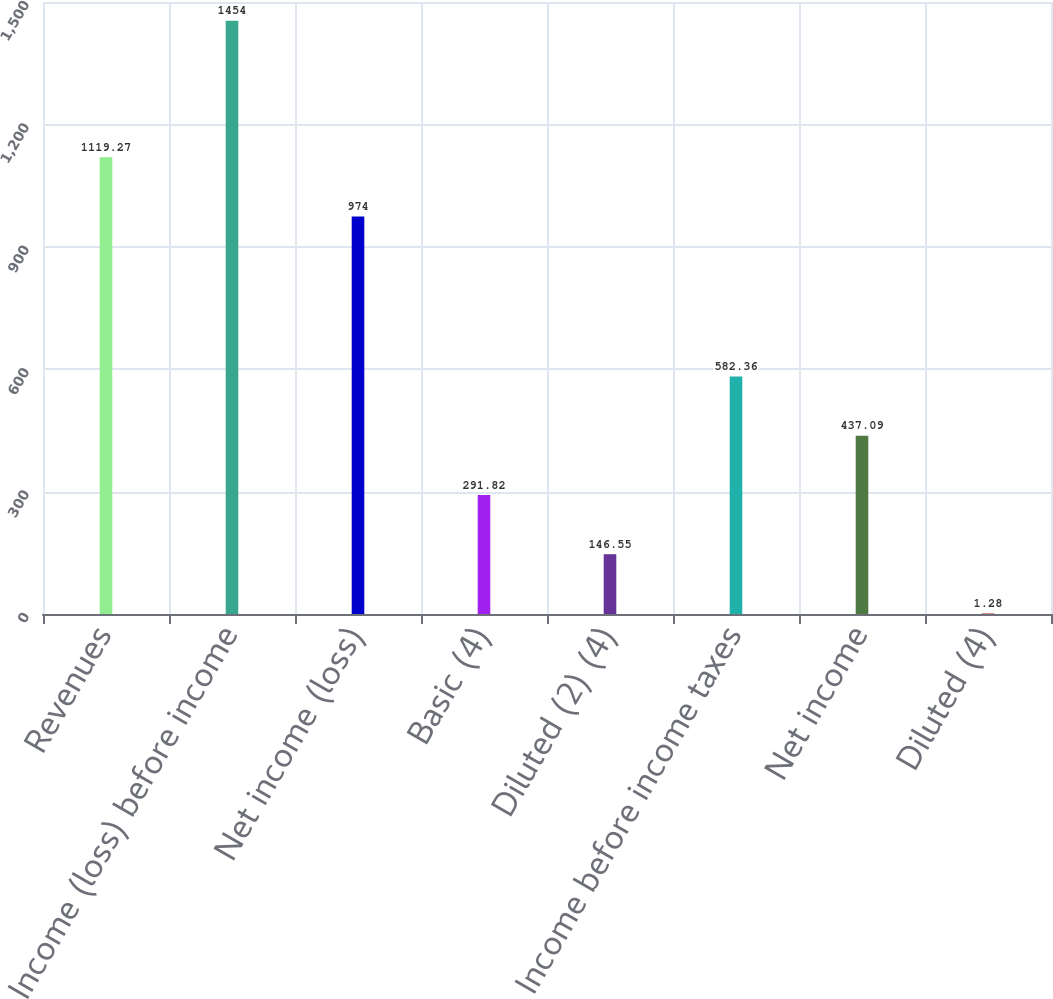<chart> <loc_0><loc_0><loc_500><loc_500><bar_chart><fcel>Revenues<fcel>Income (loss) before income<fcel>Net income (loss)<fcel>Basic (4)<fcel>Diluted (2) (4)<fcel>Income before income taxes<fcel>Net income<fcel>Diluted (4)<nl><fcel>1119.27<fcel>1454<fcel>974<fcel>291.82<fcel>146.55<fcel>582.36<fcel>437.09<fcel>1.28<nl></chart> 